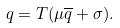<formula> <loc_0><loc_0><loc_500><loc_500>q = T ( \mu \overline { q } + \sigma ) .</formula> 